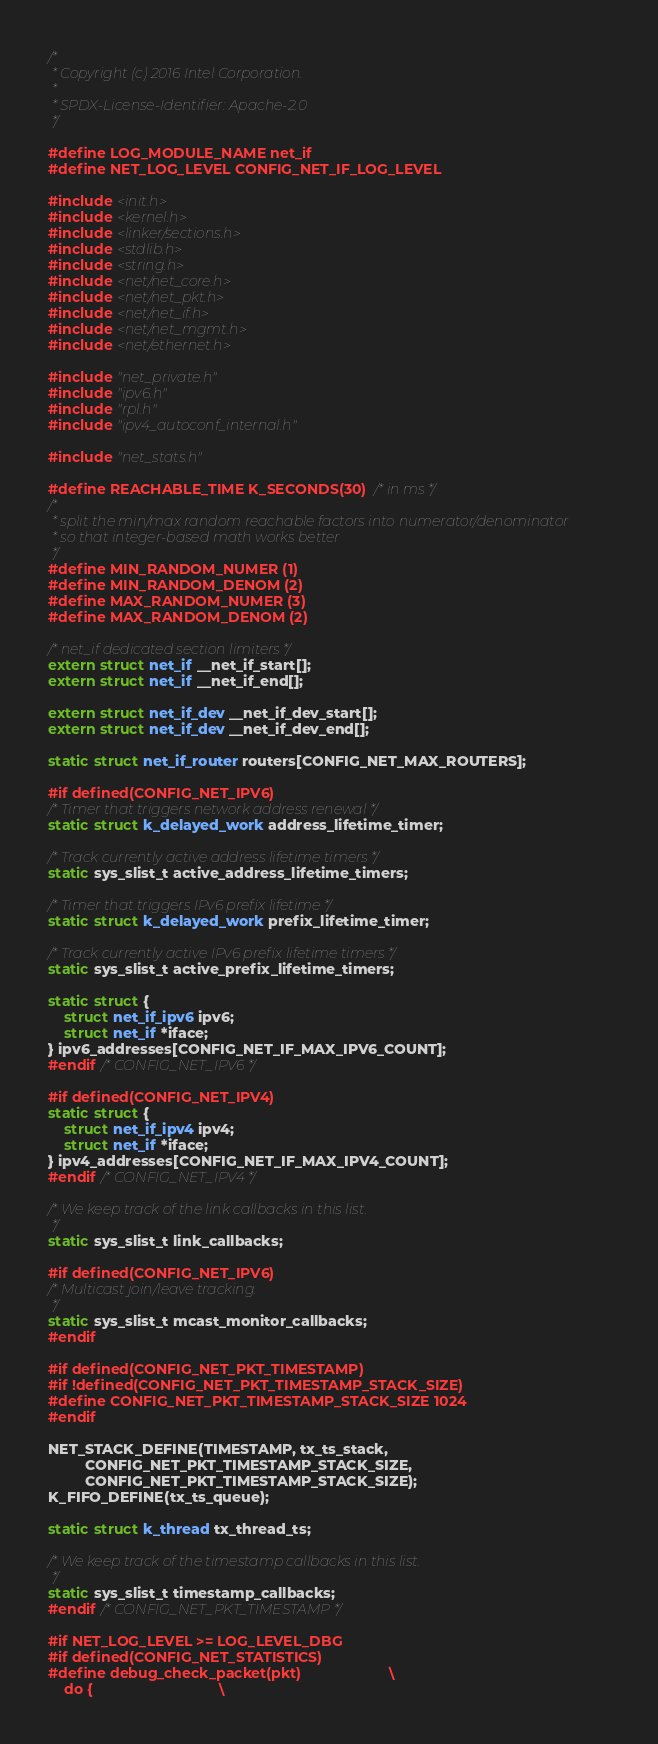<code> <loc_0><loc_0><loc_500><loc_500><_C_>/*
 * Copyright (c) 2016 Intel Corporation.
 *
 * SPDX-License-Identifier: Apache-2.0
 */

#define LOG_MODULE_NAME net_if
#define NET_LOG_LEVEL CONFIG_NET_IF_LOG_LEVEL

#include <init.h>
#include <kernel.h>
#include <linker/sections.h>
#include <stdlib.h>
#include <string.h>
#include <net/net_core.h>
#include <net/net_pkt.h>
#include <net/net_if.h>
#include <net/net_mgmt.h>
#include <net/ethernet.h>

#include "net_private.h"
#include "ipv6.h"
#include "rpl.h"
#include "ipv4_autoconf_internal.h"

#include "net_stats.h"

#define REACHABLE_TIME K_SECONDS(30) /* in ms */
/*
 * split the min/max random reachable factors into numerator/denominator
 * so that integer-based math works better
 */
#define MIN_RANDOM_NUMER (1)
#define MIN_RANDOM_DENOM (2)
#define MAX_RANDOM_NUMER (3)
#define MAX_RANDOM_DENOM (2)

/* net_if dedicated section limiters */
extern struct net_if __net_if_start[];
extern struct net_if __net_if_end[];

extern struct net_if_dev __net_if_dev_start[];
extern struct net_if_dev __net_if_dev_end[];

static struct net_if_router routers[CONFIG_NET_MAX_ROUTERS];

#if defined(CONFIG_NET_IPV6)
/* Timer that triggers network address renewal */
static struct k_delayed_work address_lifetime_timer;

/* Track currently active address lifetime timers */
static sys_slist_t active_address_lifetime_timers;

/* Timer that triggers IPv6 prefix lifetime */
static struct k_delayed_work prefix_lifetime_timer;

/* Track currently active IPv6 prefix lifetime timers */
static sys_slist_t active_prefix_lifetime_timers;

static struct {
	struct net_if_ipv6 ipv6;
	struct net_if *iface;
} ipv6_addresses[CONFIG_NET_IF_MAX_IPV6_COUNT];
#endif /* CONFIG_NET_IPV6 */

#if defined(CONFIG_NET_IPV4)
static struct {
	struct net_if_ipv4 ipv4;
	struct net_if *iface;
} ipv4_addresses[CONFIG_NET_IF_MAX_IPV4_COUNT];
#endif /* CONFIG_NET_IPV4 */

/* We keep track of the link callbacks in this list.
 */
static sys_slist_t link_callbacks;

#if defined(CONFIG_NET_IPV6)
/* Multicast join/leave tracking.
 */
static sys_slist_t mcast_monitor_callbacks;
#endif

#if defined(CONFIG_NET_PKT_TIMESTAMP)
#if !defined(CONFIG_NET_PKT_TIMESTAMP_STACK_SIZE)
#define CONFIG_NET_PKT_TIMESTAMP_STACK_SIZE 1024
#endif

NET_STACK_DEFINE(TIMESTAMP, tx_ts_stack,
		 CONFIG_NET_PKT_TIMESTAMP_STACK_SIZE,
		 CONFIG_NET_PKT_TIMESTAMP_STACK_SIZE);
K_FIFO_DEFINE(tx_ts_queue);

static struct k_thread tx_thread_ts;

/* We keep track of the timestamp callbacks in this list.
 */
static sys_slist_t timestamp_callbacks;
#endif /* CONFIG_NET_PKT_TIMESTAMP */

#if NET_LOG_LEVEL >= LOG_LEVEL_DBG
#if defined(CONFIG_NET_STATISTICS)
#define debug_check_packet(pkt)						\
	do {								\</code> 